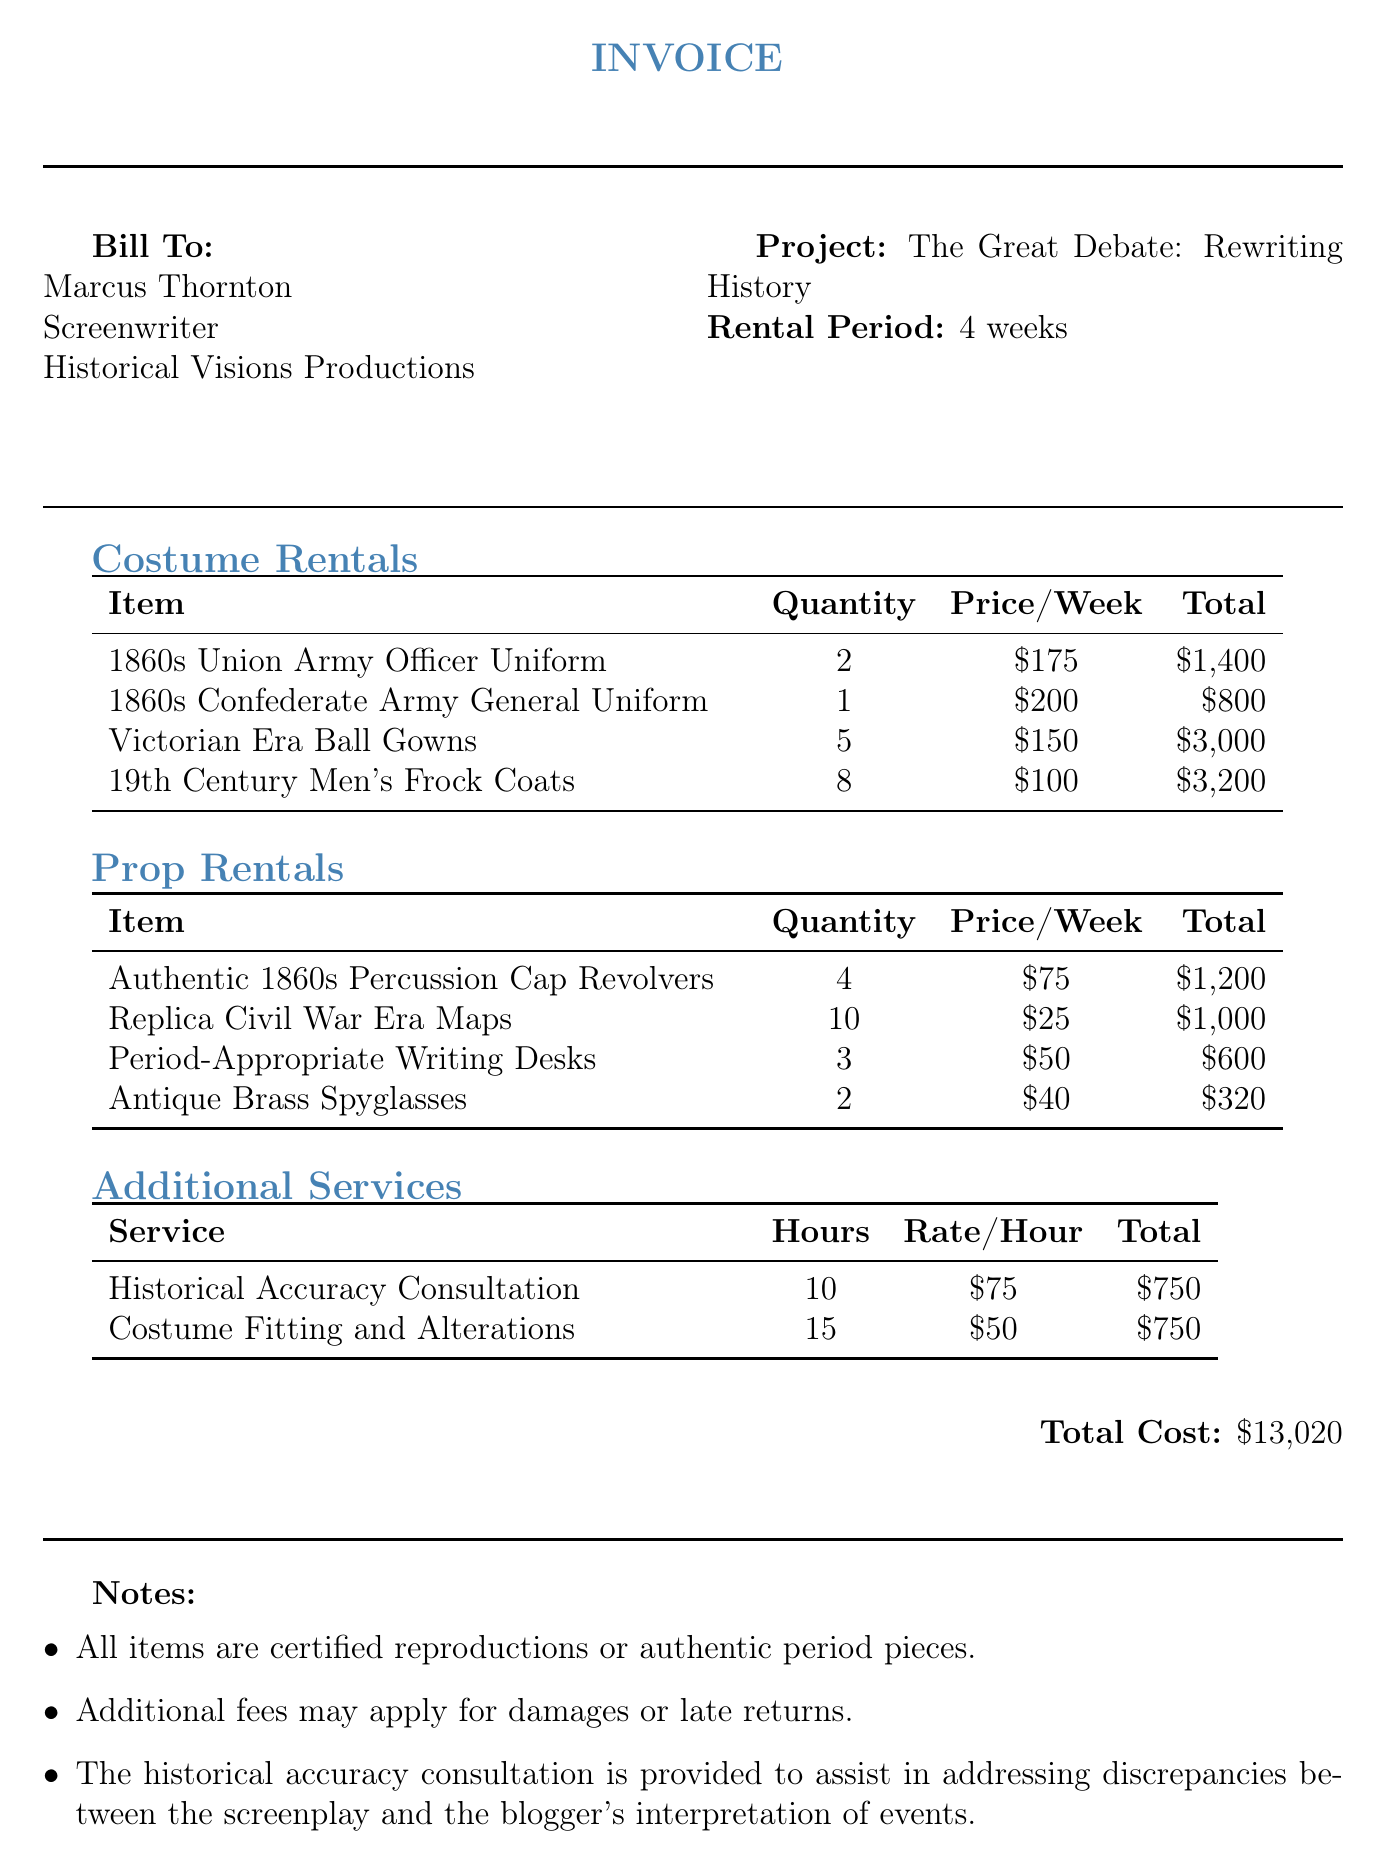What is the name of the client? The client's name is located at the top of the document in the billing section.
Answer: Marcus Thornton What is the project title? The project title is specified under the project details in the document.
Answer: The Great Debate: Rewriting History How many weeks is the rental period? The rental period is mentioned in the project details section of the invoice.
Answer: 4 weeks What is the total cost of the invoice? The total cost is provided at the end of the document under the total cost section.
Answer: $13,020 How many Victorian Era Ball Gowns were rented? The quantity of Victorian Era Ball Gowns is listed in the costume rentals table.
Answer: 5 What service had the highest total cost? Comparing the service totals in the additional services section reveals which one is the highest.
Answer: Costume Fitting and Alterations What is the price per week for the 1860s Confederate Army General Uniform? The price per week is explicitly stated in the costume rentals table next to the item.
Answer: $200 How many Antique Brass Spyglasses were rented? The quantity of Antique Brass Spyglasses is indicated in the prop rentals table.
Answer: 2 What will the additional fees apply to according to the notes? The notes specify conditions under which additional fees would apply.
Answer: Damages or late returns 